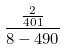<formula> <loc_0><loc_0><loc_500><loc_500>\frac { \frac { 2 } { 4 0 1 } } { 8 - 4 9 0 }</formula> 